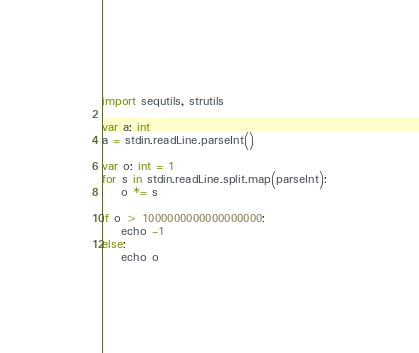Convert code to text. <code><loc_0><loc_0><loc_500><loc_500><_Nim_>import sequtils, strutils

var a: int
a = stdin.readLine.parseInt()

var o: int = 1
for s in stdin.readLine.split.map(parseInt):
    o *= s

if o > 1000000000000000000:
    echo -1
else:
    echo o
</code> 